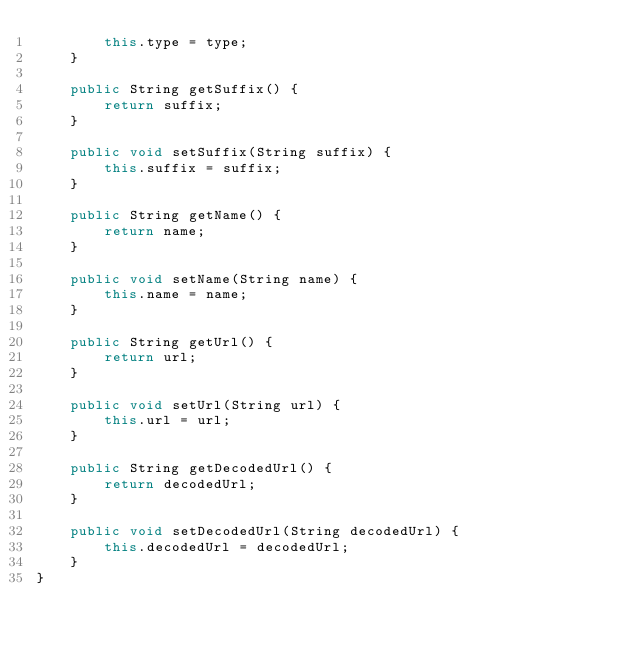<code> <loc_0><loc_0><loc_500><loc_500><_Java_>        this.type = type;
    }

    public String getSuffix() {
        return suffix;
    }

    public void setSuffix(String suffix) {
        this.suffix = suffix;
    }

    public String getName() {
        return name;
    }

    public void setName(String name) {
        this.name = name;
    }

    public String getUrl() {
        return url;
    }

    public void setUrl(String url) {
        this.url = url;
    }

    public String getDecodedUrl() {
        return decodedUrl;
    }

    public void setDecodedUrl(String decodedUrl) {
        this.decodedUrl = decodedUrl;
    }
}
</code> 